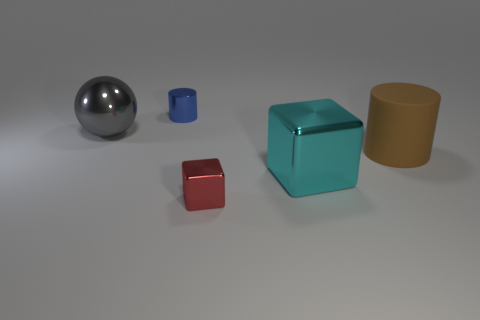Add 2 tiny red metallic blocks. How many objects exist? 7 Subtract 1 cylinders. How many cylinders are left? 1 Subtract all cubes. How many objects are left? 3 Subtract all large cyan metallic cubes. Subtract all big spheres. How many objects are left? 3 Add 2 red blocks. How many red blocks are left? 3 Add 2 gray metal spheres. How many gray metal spheres exist? 3 Subtract 0 blue spheres. How many objects are left? 5 Subtract all green cylinders. Subtract all blue spheres. How many cylinders are left? 2 